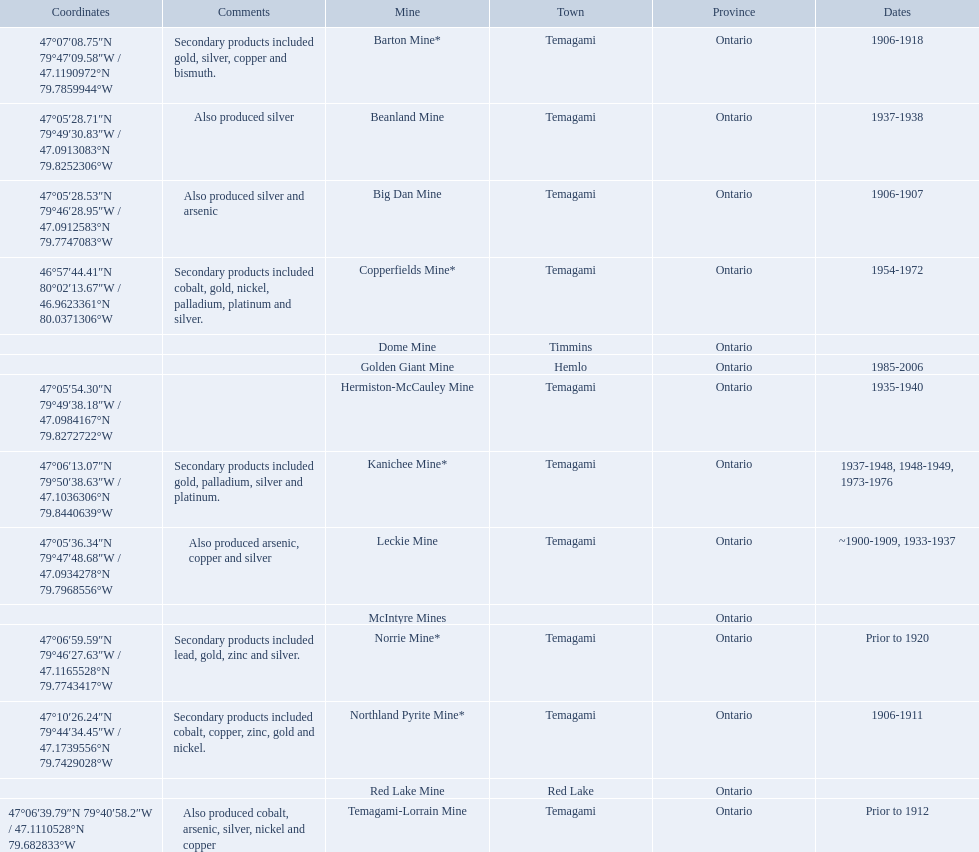What years was the golden giant mine open for? 1985-2006. What years was the beanland mine open? 1937-1938. Which of these two mines was open longer? Golden Giant Mine. 